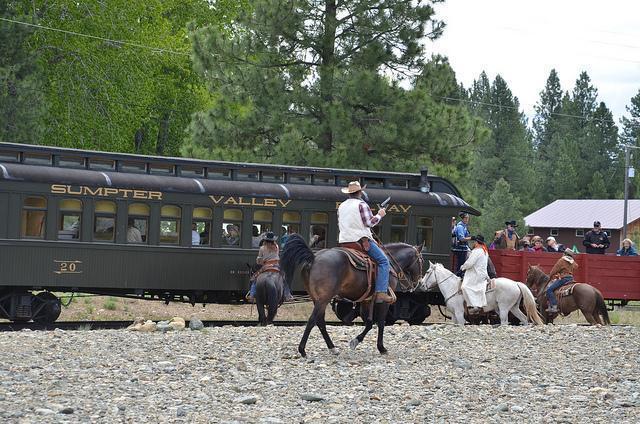What are the men on horses dressed as?
Choose the correct response and explain in the format: 'Answer: answer
Rationale: rationale.'
Options: Cowboys, indians, police, ghosts. Answer: cowboys.
Rationale: They are doing a western act for the folks on the train. 